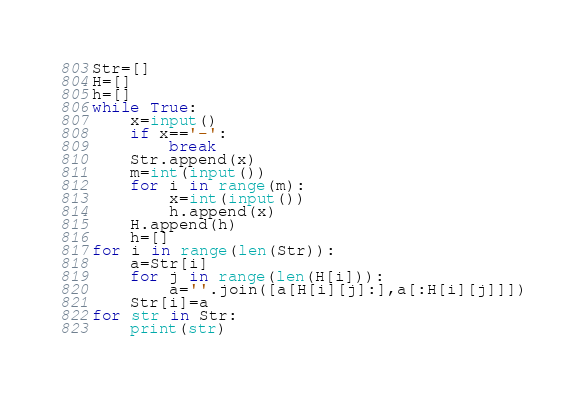<code> <loc_0><loc_0><loc_500><loc_500><_Python_>Str=[]
H=[]
h=[]
while True:
    x=input()
    if x=='-':
        break
    Str.append(x)
    m=int(input())
    for i in range(m):
        x=int(input())
        h.append(x)
    H.append(h)
    h=[]
for i in range(len(Str)):
    a=Str[i]
    for j in range(len(H[i])):
        a=''.join([a[H[i][j]:],a[:H[i][j]]])
    Str[i]=a
for str in Str:
    print(str)</code> 